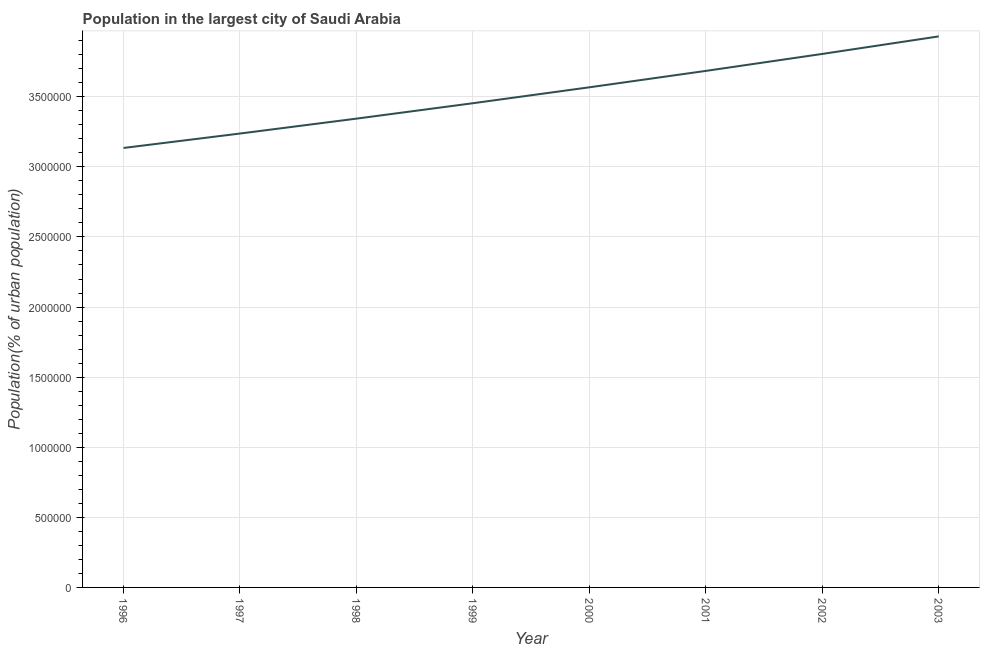What is the population in largest city in 2003?
Offer a very short reply. 3.93e+06. Across all years, what is the maximum population in largest city?
Your answer should be very brief. 3.93e+06. Across all years, what is the minimum population in largest city?
Provide a short and direct response. 3.13e+06. In which year was the population in largest city maximum?
Your response must be concise. 2003. In which year was the population in largest city minimum?
Make the answer very short. 1996. What is the sum of the population in largest city?
Offer a terse response. 2.82e+07. What is the difference between the population in largest city in 1999 and 2002?
Your answer should be compact. -3.52e+05. What is the average population in largest city per year?
Offer a very short reply. 3.52e+06. What is the median population in largest city?
Provide a succinct answer. 3.51e+06. What is the ratio of the population in largest city in 2000 to that in 2002?
Your answer should be very brief. 0.94. What is the difference between the highest and the second highest population in largest city?
Offer a terse response. 1.25e+05. Is the sum of the population in largest city in 1997 and 2001 greater than the maximum population in largest city across all years?
Your answer should be very brief. Yes. What is the difference between the highest and the lowest population in largest city?
Your answer should be very brief. 7.96e+05. Does the population in largest city monotonically increase over the years?
Provide a short and direct response. Yes. How many lines are there?
Make the answer very short. 1. What is the difference between two consecutive major ticks on the Y-axis?
Make the answer very short. 5.00e+05. Are the values on the major ticks of Y-axis written in scientific E-notation?
Ensure brevity in your answer.  No. Does the graph contain grids?
Offer a terse response. Yes. What is the title of the graph?
Your response must be concise. Population in the largest city of Saudi Arabia. What is the label or title of the X-axis?
Give a very brief answer. Year. What is the label or title of the Y-axis?
Give a very brief answer. Population(% of urban population). What is the Population(% of urban population) of 1996?
Your response must be concise. 3.13e+06. What is the Population(% of urban population) of 1997?
Keep it short and to the point. 3.24e+06. What is the Population(% of urban population) in 1998?
Offer a terse response. 3.34e+06. What is the Population(% of urban population) in 1999?
Offer a very short reply. 3.45e+06. What is the Population(% of urban population) of 2000?
Your answer should be very brief. 3.57e+06. What is the Population(% of urban population) in 2001?
Your answer should be very brief. 3.68e+06. What is the Population(% of urban population) in 2002?
Offer a terse response. 3.81e+06. What is the Population(% of urban population) of 2003?
Make the answer very short. 3.93e+06. What is the difference between the Population(% of urban population) in 1996 and 1997?
Offer a very short reply. -1.03e+05. What is the difference between the Population(% of urban population) in 1996 and 1998?
Your answer should be compact. -2.09e+05. What is the difference between the Population(% of urban population) in 1996 and 1999?
Offer a very short reply. -3.19e+05. What is the difference between the Population(% of urban population) in 1996 and 2000?
Offer a very short reply. -4.33e+05. What is the difference between the Population(% of urban population) in 1996 and 2001?
Offer a very short reply. -5.50e+05. What is the difference between the Population(% of urban population) in 1996 and 2002?
Offer a very short reply. -6.71e+05. What is the difference between the Population(% of urban population) in 1996 and 2003?
Provide a short and direct response. -7.96e+05. What is the difference between the Population(% of urban population) in 1997 and 1998?
Your answer should be compact. -1.06e+05. What is the difference between the Population(% of urban population) in 1997 and 1999?
Offer a very short reply. -2.16e+05. What is the difference between the Population(% of urban population) in 1997 and 2000?
Keep it short and to the point. -3.30e+05. What is the difference between the Population(% of urban population) in 1997 and 2001?
Your answer should be very brief. -4.47e+05. What is the difference between the Population(% of urban population) in 1997 and 2002?
Provide a short and direct response. -5.68e+05. What is the difference between the Population(% of urban population) in 1997 and 2003?
Give a very brief answer. -6.93e+05. What is the difference between the Population(% of urban population) in 1998 and 1999?
Your answer should be compact. -1.10e+05. What is the difference between the Population(% of urban population) in 1998 and 2000?
Your answer should be compact. -2.23e+05. What is the difference between the Population(% of urban population) in 1998 and 2001?
Your response must be concise. -3.40e+05. What is the difference between the Population(% of urban population) in 1998 and 2002?
Offer a very short reply. -4.62e+05. What is the difference between the Population(% of urban population) in 1998 and 2003?
Your answer should be very brief. -5.87e+05. What is the difference between the Population(% of urban population) in 1999 and 2000?
Your answer should be compact. -1.14e+05. What is the difference between the Population(% of urban population) in 1999 and 2001?
Your answer should be compact. -2.31e+05. What is the difference between the Population(% of urban population) in 1999 and 2002?
Give a very brief answer. -3.52e+05. What is the difference between the Population(% of urban population) in 1999 and 2003?
Offer a very short reply. -4.77e+05. What is the difference between the Population(% of urban population) in 2000 and 2001?
Give a very brief answer. -1.17e+05. What is the difference between the Population(% of urban population) in 2000 and 2002?
Provide a succinct answer. -2.38e+05. What is the difference between the Population(% of urban population) in 2000 and 2003?
Keep it short and to the point. -3.63e+05. What is the difference between the Population(% of urban population) in 2001 and 2002?
Offer a terse response. -1.21e+05. What is the difference between the Population(% of urban population) in 2001 and 2003?
Your response must be concise. -2.46e+05. What is the difference between the Population(% of urban population) in 2002 and 2003?
Your answer should be very brief. -1.25e+05. What is the ratio of the Population(% of urban population) in 1996 to that in 1998?
Provide a short and direct response. 0.94. What is the ratio of the Population(% of urban population) in 1996 to that in 1999?
Make the answer very short. 0.91. What is the ratio of the Population(% of urban population) in 1996 to that in 2000?
Your answer should be very brief. 0.88. What is the ratio of the Population(% of urban population) in 1996 to that in 2001?
Make the answer very short. 0.85. What is the ratio of the Population(% of urban population) in 1996 to that in 2002?
Your answer should be very brief. 0.82. What is the ratio of the Population(% of urban population) in 1996 to that in 2003?
Give a very brief answer. 0.8. What is the ratio of the Population(% of urban population) in 1997 to that in 1999?
Ensure brevity in your answer.  0.94. What is the ratio of the Population(% of urban population) in 1997 to that in 2000?
Ensure brevity in your answer.  0.91. What is the ratio of the Population(% of urban population) in 1997 to that in 2001?
Keep it short and to the point. 0.88. What is the ratio of the Population(% of urban population) in 1997 to that in 2002?
Provide a short and direct response. 0.85. What is the ratio of the Population(% of urban population) in 1997 to that in 2003?
Your response must be concise. 0.82. What is the ratio of the Population(% of urban population) in 1998 to that in 2000?
Provide a short and direct response. 0.94. What is the ratio of the Population(% of urban population) in 1998 to that in 2001?
Your response must be concise. 0.91. What is the ratio of the Population(% of urban population) in 1998 to that in 2002?
Provide a short and direct response. 0.88. What is the ratio of the Population(% of urban population) in 1998 to that in 2003?
Provide a succinct answer. 0.85. What is the ratio of the Population(% of urban population) in 1999 to that in 2000?
Offer a very short reply. 0.97. What is the ratio of the Population(% of urban population) in 1999 to that in 2001?
Offer a terse response. 0.94. What is the ratio of the Population(% of urban population) in 1999 to that in 2002?
Provide a short and direct response. 0.91. What is the ratio of the Population(% of urban population) in 1999 to that in 2003?
Give a very brief answer. 0.88. What is the ratio of the Population(% of urban population) in 2000 to that in 2001?
Offer a terse response. 0.97. What is the ratio of the Population(% of urban population) in 2000 to that in 2002?
Your answer should be compact. 0.94. What is the ratio of the Population(% of urban population) in 2000 to that in 2003?
Ensure brevity in your answer.  0.91. What is the ratio of the Population(% of urban population) in 2001 to that in 2003?
Your answer should be very brief. 0.94. 